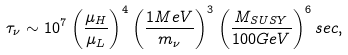<formula> <loc_0><loc_0><loc_500><loc_500>\tau _ { \nu } \sim 1 0 ^ { 7 } \left ( \frac { \mu _ { H } } { \mu _ { L } } \right ) ^ { 4 } \left ( \frac { 1 { M e V } } { m _ { \nu } } \right ) ^ { 3 } \left ( \frac { M _ { S U S Y } } { 1 0 0 { G e V } } \right ) ^ { 6 } { s e c } ,</formula> 